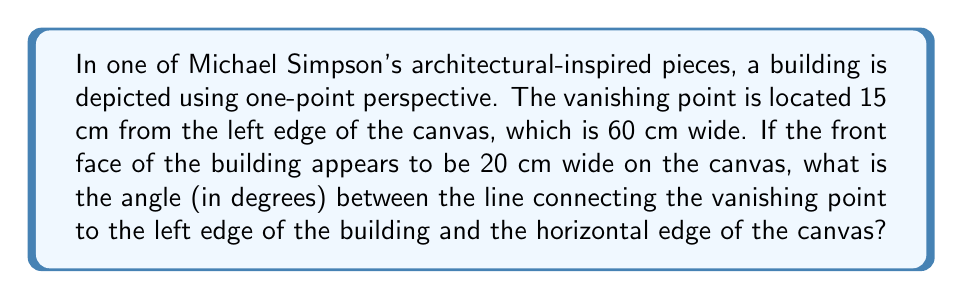Provide a solution to this math problem. Let's approach this step-by-step:

1) First, let's visualize the problem:

[asy]
unitsize(0.1cm);
pair VP = (15,0);
pair A = (0,0);
pair B = (60,0);
pair C = (25,-20);
pair D = (45,-20);

draw(A--B);
draw(VP--C);
draw(VP--D);
draw(C--D);

label("VP", VP, N);
label("A", A, SW);
label("B", B, SE);
label("C", C, S);
label("D", D, S);
label("15 cm", (7.5,0), N);
label("20 cm", (35,-20), S);
label("60 cm", (30,0), N);

dot(VP);
dot(A);
dot(B);
dot(C);
dot(D);
[/asy]

2) We need to find the angle between VP-C and the horizontal line.

3) We can treat this as a right-angled triangle, where:
   - The base is the distance from VP to C horizontally (10 cm)
   - The height is the vertical distance from the horizontal line to point C

4) We know the width of the building on the canvas (20 cm), so half of this (10 cm) is the distance from the center of the building to its edge.

5) We can use the tangent function to find this angle:

   $$\tan(\theta) = \frac{\text{opposite}}{\text{adjacent}} = \frac{10}{10} = 1$$

6) To find the angle, we use the arctangent (inverse tangent) function:

   $$\theta = \arctan(1)$$

7) The arctangent of 1 is equal to π/4 radians, or 45 degrees.
Answer: 45° 